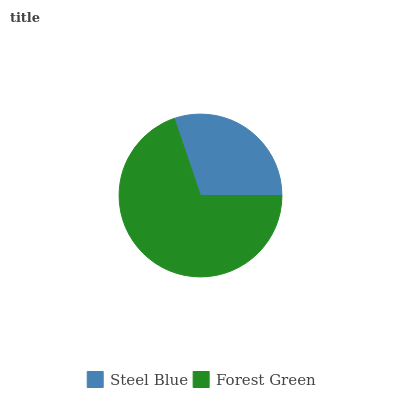Is Steel Blue the minimum?
Answer yes or no. Yes. Is Forest Green the maximum?
Answer yes or no. Yes. Is Forest Green the minimum?
Answer yes or no. No. Is Forest Green greater than Steel Blue?
Answer yes or no. Yes. Is Steel Blue less than Forest Green?
Answer yes or no. Yes. Is Steel Blue greater than Forest Green?
Answer yes or no. No. Is Forest Green less than Steel Blue?
Answer yes or no. No. Is Forest Green the high median?
Answer yes or no. Yes. Is Steel Blue the low median?
Answer yes or no. Yes. Is Steel Blue the high median?
Answer yes or no. No. Is Forest Green the low median?
Answer yes or no. No. 